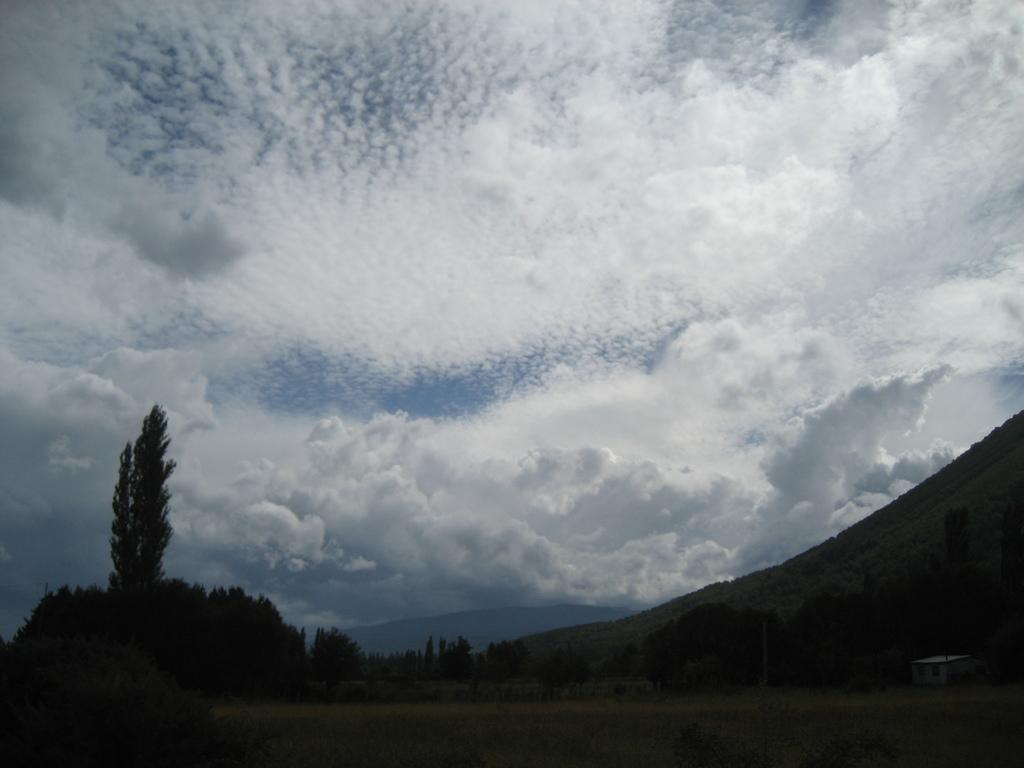What type of structure is visible in the image? There is a shed in the image. What can be seen in the background of the image? There are trees, mountains, and the sky visible in the background of the image. What is the condition of the sky in the image? Clouds are present in the sky in the image. What type of glass is being used as a guide in the image? There is no glass or guide present in the image. 